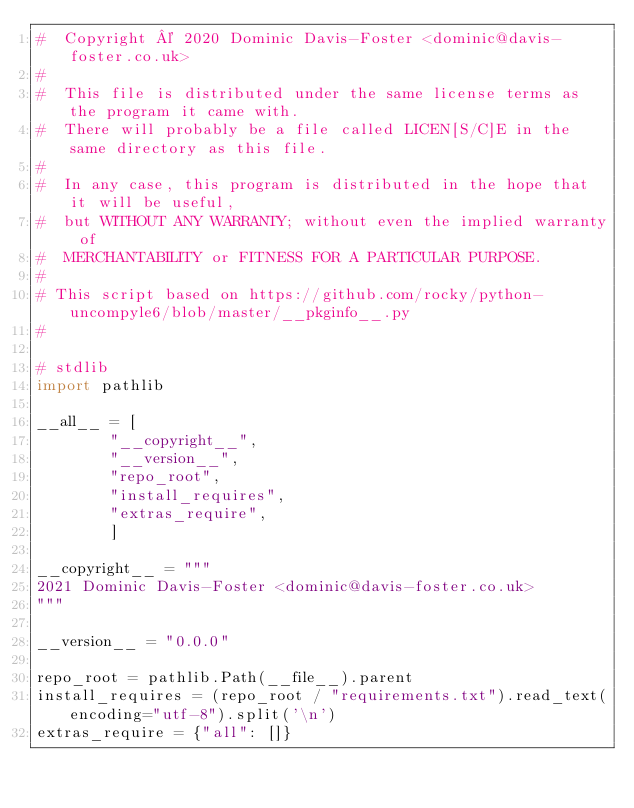Convert code to text. <code><loc_0><loc_0><loc_500><loc_500><_Python_>#  Copyright © 2020 Dominic Davis-Foster <dominic@davis-foster.co.uk>
#
#  This file is distributed under the same license terms as the program it came with.
#  There will probably be a file called LICEN[S/C]E in the same directory as this file.
#
#  In any case, this program is distributed in the hope that it will be useful,
#  but WITHOUT ANY WARRANTY; without even the implied warranty of
#  MERCHANTABILITY or FITNESS FOR A PARTICULAR PURPOSE.
#
# This script based on https://github.com/rocky/python-uncompyle6/blob/master/__pkginfo__.py
#

# stdlib
import pathlib

__all__ = [
		"__copyright__",
		"__version__",
		"repo_root",
		"install_requires",
		"extras_require",
		]

__copyright__ = """
2021 Dominic Davis-Foster <dominic@davis-foster.co.uk>
"""

__version__ = "0.0.0"

repo_root = pathlib.Path(__file__).parent
install_requires = (repo_root / "requirements.txt").read_text(encoding="utf-8").split('\n')
extras_require = {"all": []}
</code> 